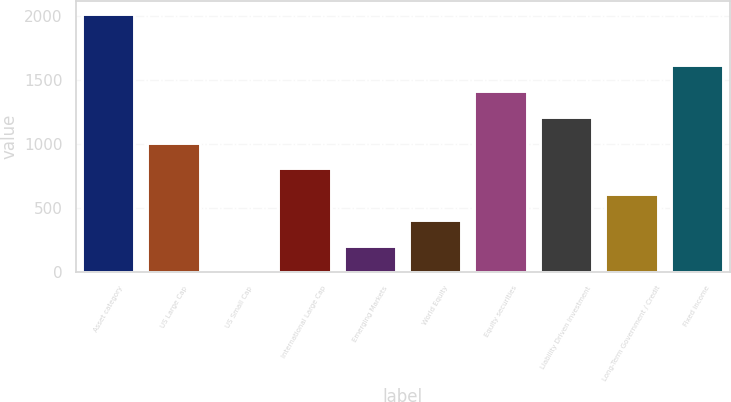Convert chart. <chart><loc_0><loc_0><loc_500><loc_500><bar_chart><fcel>Asset category<fcel>US Large Cap<fcel>US Small Cap<fcel>International Large Cap<fcel>Emerging Markets<fcel>World Equity<fcel>Equity securities<fcel>Liability Driven Investment<fcel>Long-Term Government / Credit<fcel>Fixed income<nl><fcel>2015<fcel>1009.5<fcel>4<fcel>808.4<fcel>205.1<fcel>406.2<fcel>1411.7<fcel>1210.6<fcel>607.3<fcel>1612.8<nl></chart> 